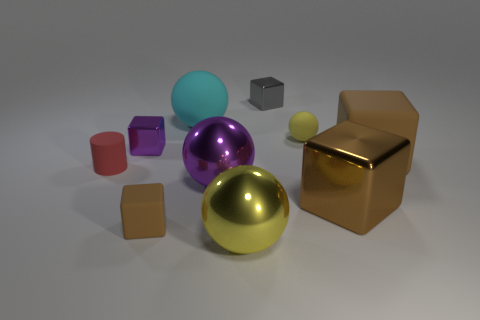How many brown cubes must be subtracted to get 1 brown cubes? 2 Subtract all small brown blocks. How many blocks are left? 4 Subtract all red cylinders. How many brown blocks are left? 3 Subtract all balls. How many objects are left? 6 Subtract all purple blocks. How many blocks are left? 4 Subtract 1 balls. How many balls are left? 3 Subtract all tiny purple cubes. Subtract all yellow metallic things. How many objects are left? 8 Add 8 large brown things. How many large brown things are left? 10 Add 3 small brown metal balls. How many small brown metal balls exist? 3 Subtract 0 cyan cubes. How many objects are left? 10 